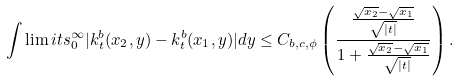Convert formula to latex. <formula><loc_0><loc_0><loc_500><loc_500>\int \lim i t s _ { 0 } ^ { \infty } | k ^ { b } _ { t } ( x _ { 2 } , y ) - k ^ { b } _ { t } ( x _ { 1 } , y ) | d y \leq C _ { b , c , \phi } \left ( \frac { \frac { \sqrt { x _ { 2 } } - \sqrt { x _ { 1 } } } { \sqrt { | t | } } } { 1 + \frac { \sqrt { x _ { 2 } } - \sqrt { x _ { 1 } } } { \sqrt { | t | } } } \right ) .</formula> 